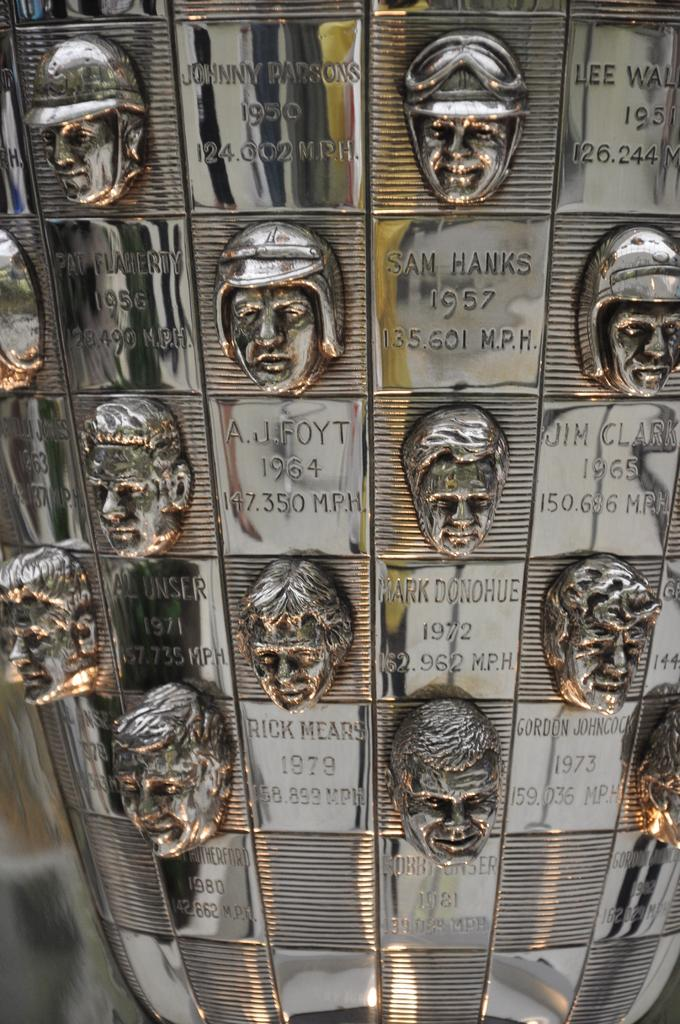What type of material is the main object in the image made of? The main object in the image is made of metal. What can be observed about the design of the metal object? The metal object has different faces on it. Is there any text present on the metal object? Yes, there is text on the metal object. What type of drum is being played in the image? There is no drum present in the image; it features a metal object with different faces and text. 